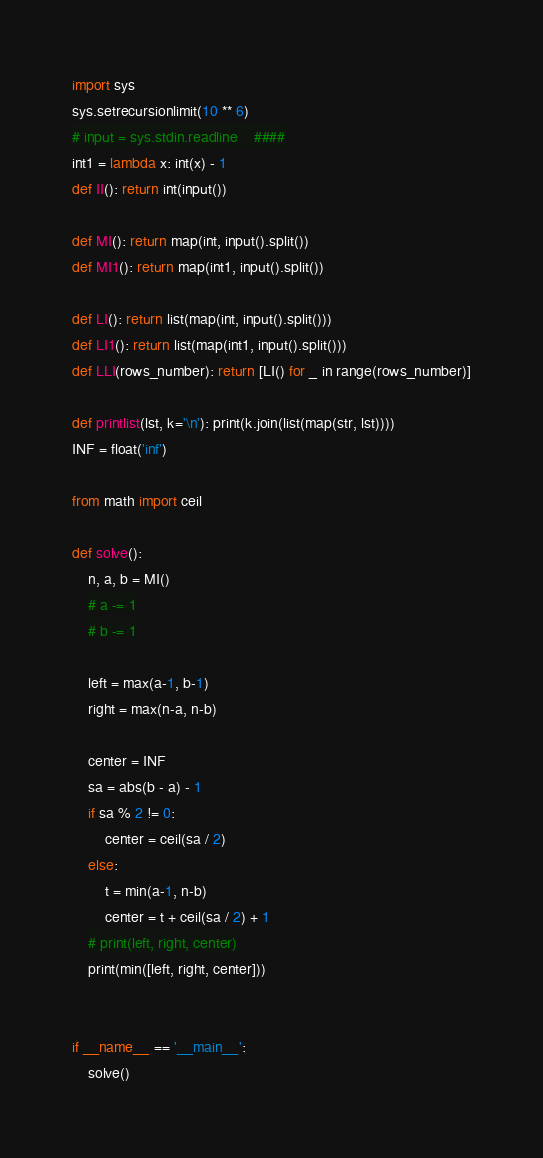Convert code to text. <code><loc_0><loc_0><loc_500><loc_500><_Python_>import sys
sys.setrecursionlimit(10 ** 6)
# input = sys.stdin.readline    ####
int1 = lambda x: int(x) - 1
def II(): return int(input())

def MI(): return map(int, input().split())
def MI1(): return map(int1, input().split())

def LI(): return list(map(int, input().split()))
def LI1(): return list(map(int1, input().split()))
def LLI(rows_number): return [LI() for _ in range(rows_number)]

def printlist(lst, k='\n'): print(k.join(list(map(str, lst))))
INF = float('inf')

from math import ceil

def solve():
    n, a, b = MI()
    # a -= 1
    # b -= 1

    left = max(a-1, b-1)
    right = max(n-a, n-b)

    center = INF
    sa = abs(b - a) - 1
    if sa % 2 != 0:
        center = ceil(sa / 2)
    else:
        t = min(a-1, n-b)
        center = t + ceil(sa / 2) + 1
    # print(left, right, center)
    print(min([left, right, center]))


if __name__ == '__main__':
    solve()
</code> 